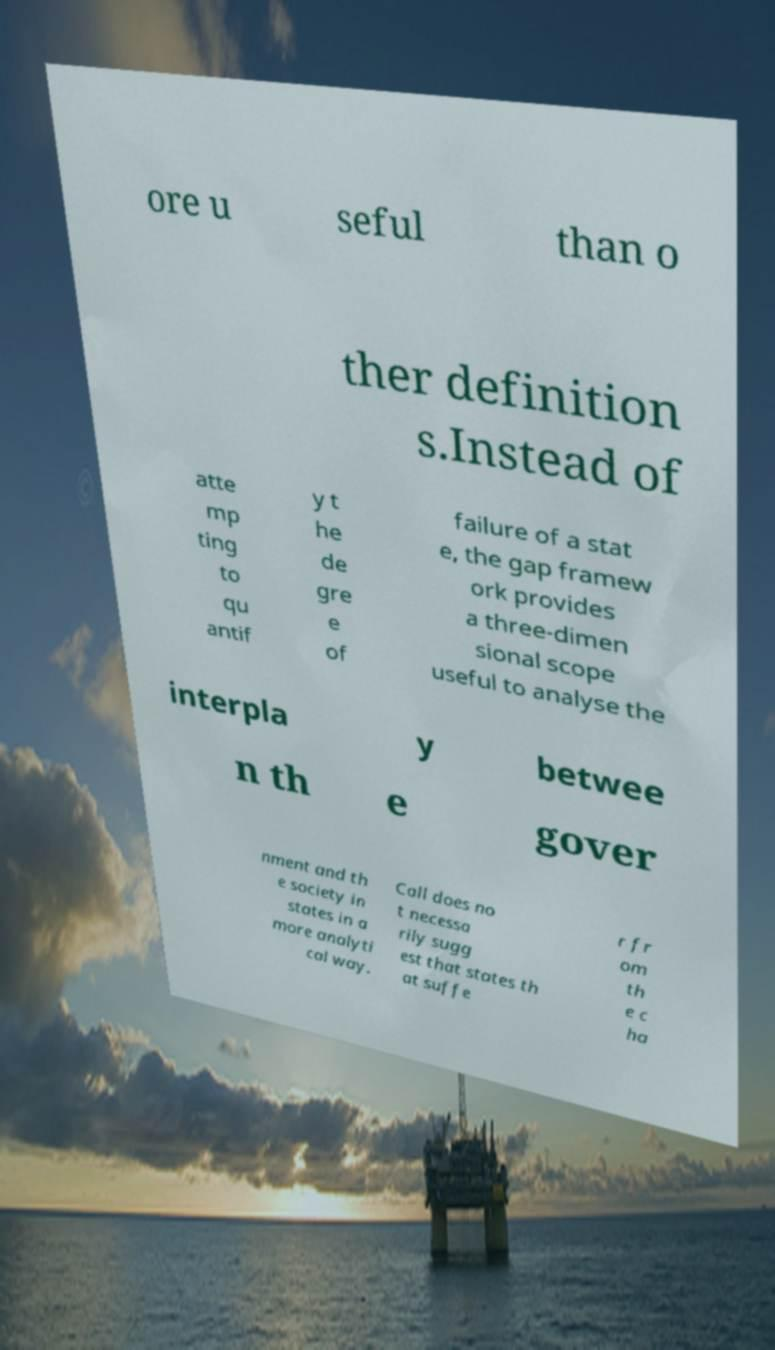Could you extract and type out the text from this image? ore u seful than o ther definition s.Instead of atte mp ting to qu antif y t he de gre e of failure of a stat e, the gap framew ork provides a three-dimen sional scope useful to analyse the interpla y betwee n th e gover nment and th e society in states in a more analyti cal way. Call does no t necessa rily sugg est that states th at suffe r fr om th e c ha 